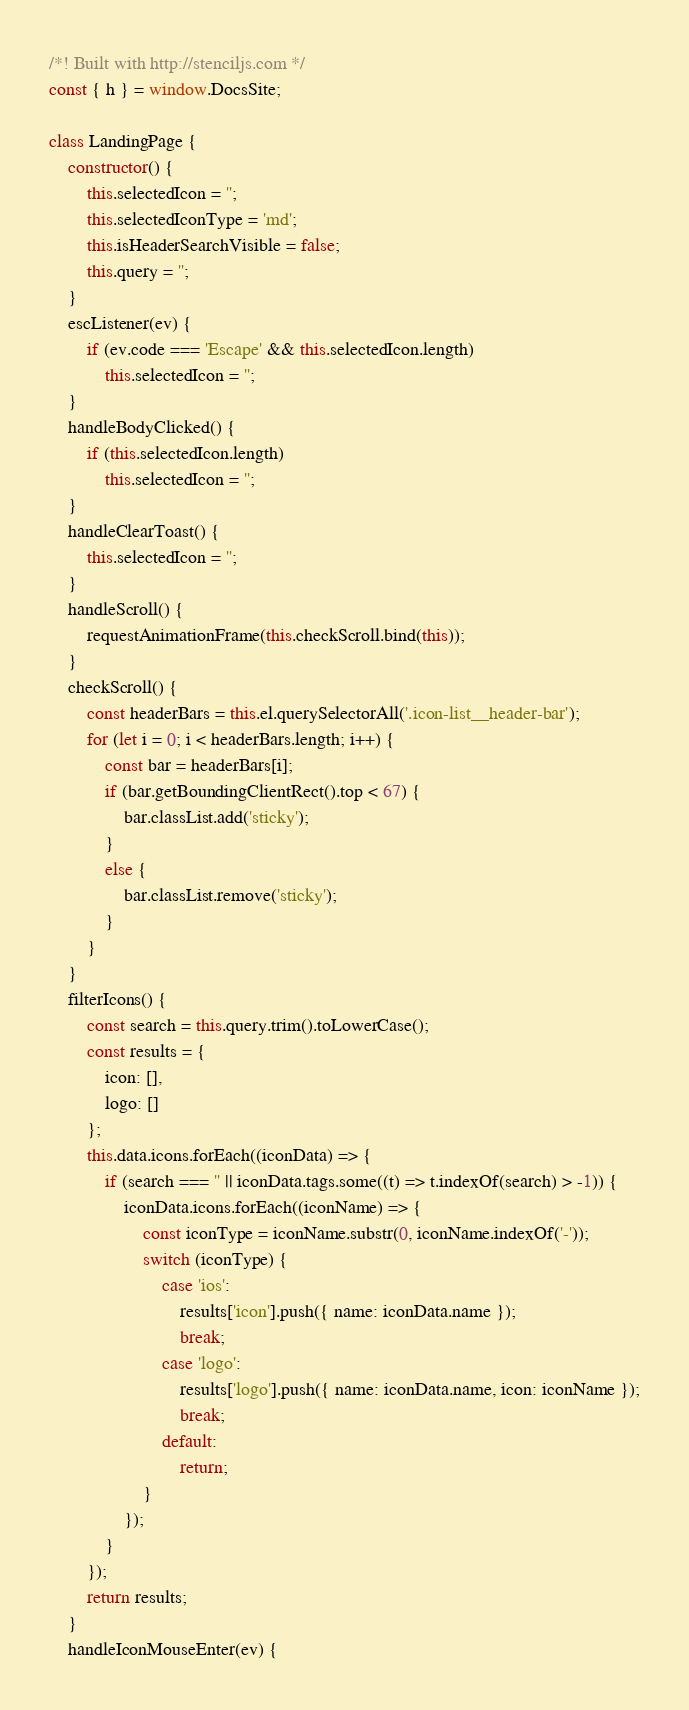<code> <loc_0><loc_0><loc_500><loc_500><_JavaScript_>/*! Built with http://stenciljs.com */
const { h } = window.DocsSite;

class LandingPage {
    constructor() {
        this.selectedIcon = '';
        this.selectedIconType = 'md';
        this.isHeaderSearchVisible = false;
        this.query = '';
    }
    escListener(ev) {
        if (ev.code === 'Escape' && this.selectedIcon.length)
            this.selectedIcon = '';
    }
    handleBodyClicked() {
        if (this.selectedIcon.length)
            this.selectedIcon = '';
    }
    handleClearToast() {
        this.selectedIcon = '';
    }
    handleScroll() {
        requestAnimationFrame(this.checkScroll.bind(this));
    }
    checkScroll() {
        const headerBars = this.el.querySelectorAll('.icon-list__header-bar');
        for (let i = 0; i < headerBars.length; i++) {
            const bar = headerBars[i];
            if (bar.getBoundingClientRect().top < 67) {
                bar.classList.add('sticky');
            }
            else {
                bar.classList.remove('sticky');
            }
        }
    }
    filterIcons() {
        const search = this.query.trim().toLowerCase();
        const results = {
            icon: [],
            logo: []
        };
        this.data.icons.forEach((iconData) => {
            if (search === '' || iconData.tags.some((t) => t.indexOf(search) > -1)) {
                iconData.icons.forEach((iconName) => {
                    const iconType = iconName.substr(0, iconName.indexOf('-'));
                    switch (iconType) {
                        case 'ios':
                            results['icon'].push({ name: iconData.name });
                            break;
                        case 'logo':
                            results['logo'].push({ name: iconData.name, icon: iconName });
                            break;
                        default:
                            return;
                    }
                });
            }
        });
        return results;
    }
    handleIconMouseEnter(ev) {</code> 